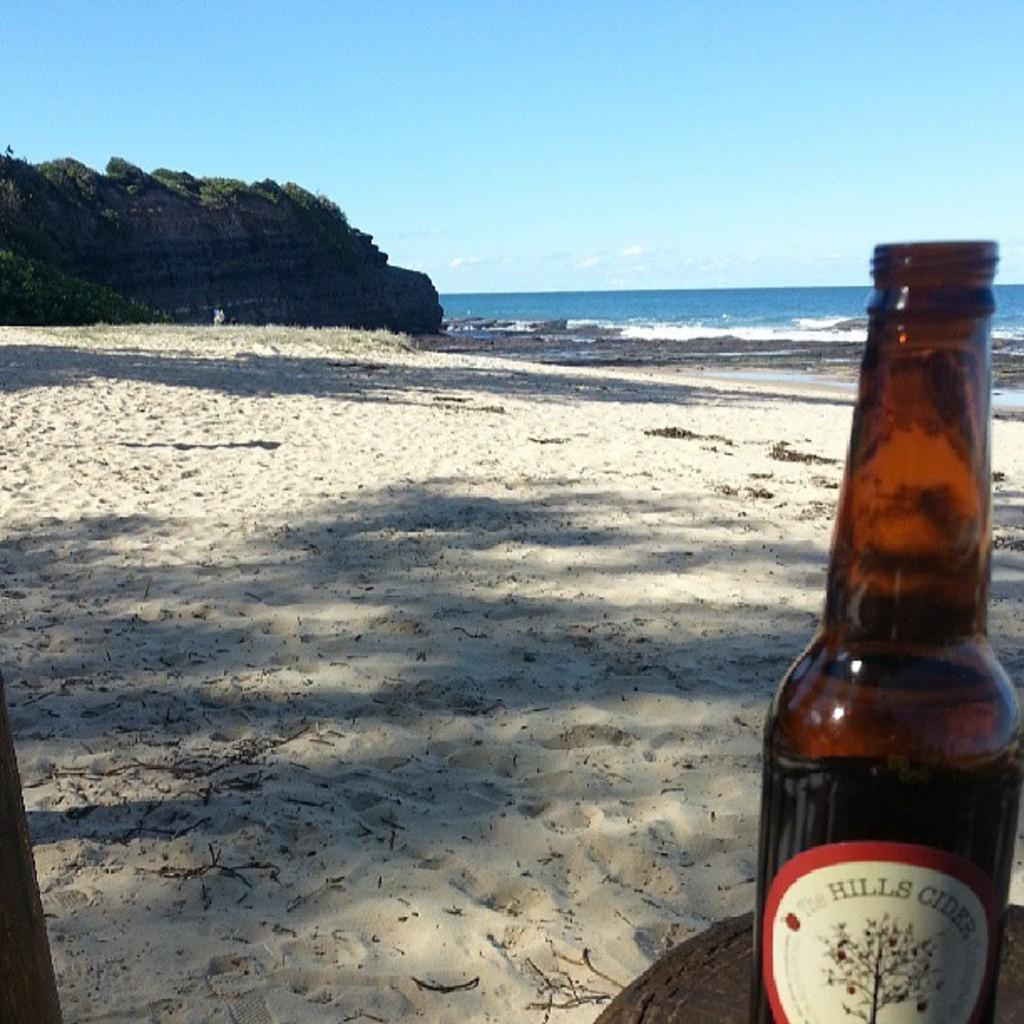What object can be seen in the image? There is a bottle in the image. What type of terrain is visible in the image? There is sand visible in the image. What natural element is present in the image? There is water in the image. What is visible in the background of the image? The sky is visible in the image. Can you see a squirrel carrying a carriage in the image? There is no squirrel or carriage present in the image. 